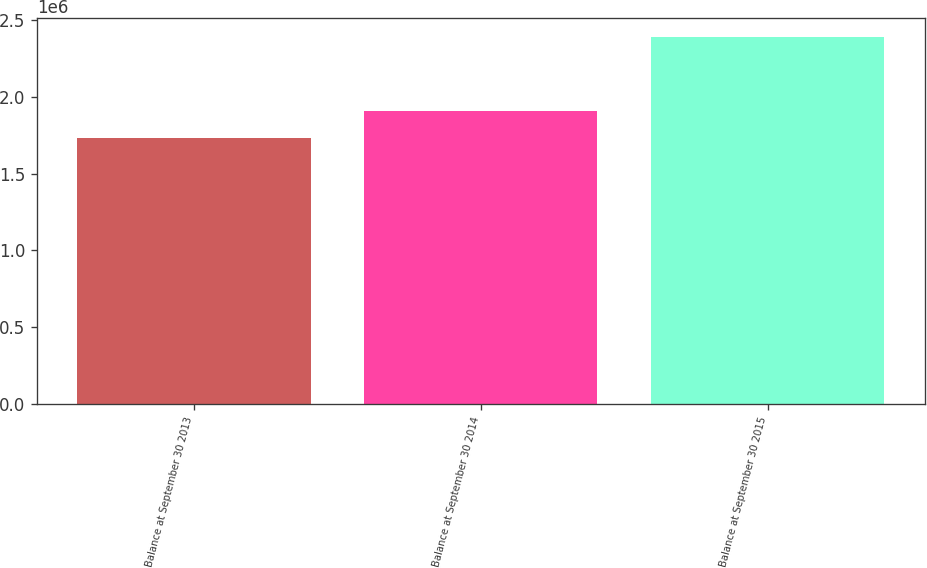Convert chart to OTSL. <chart><loc_0><loc_0><loc_500><loc_500><bar_chart><fcel>Balance at September 30 2013<fcel>Balance at September 30 2014<fcel>Balance at September 30 2015<nl><fcel>1.73452e+06<fcel>1.90626e+06<fcel>2.39241e+06<nl></chart> 